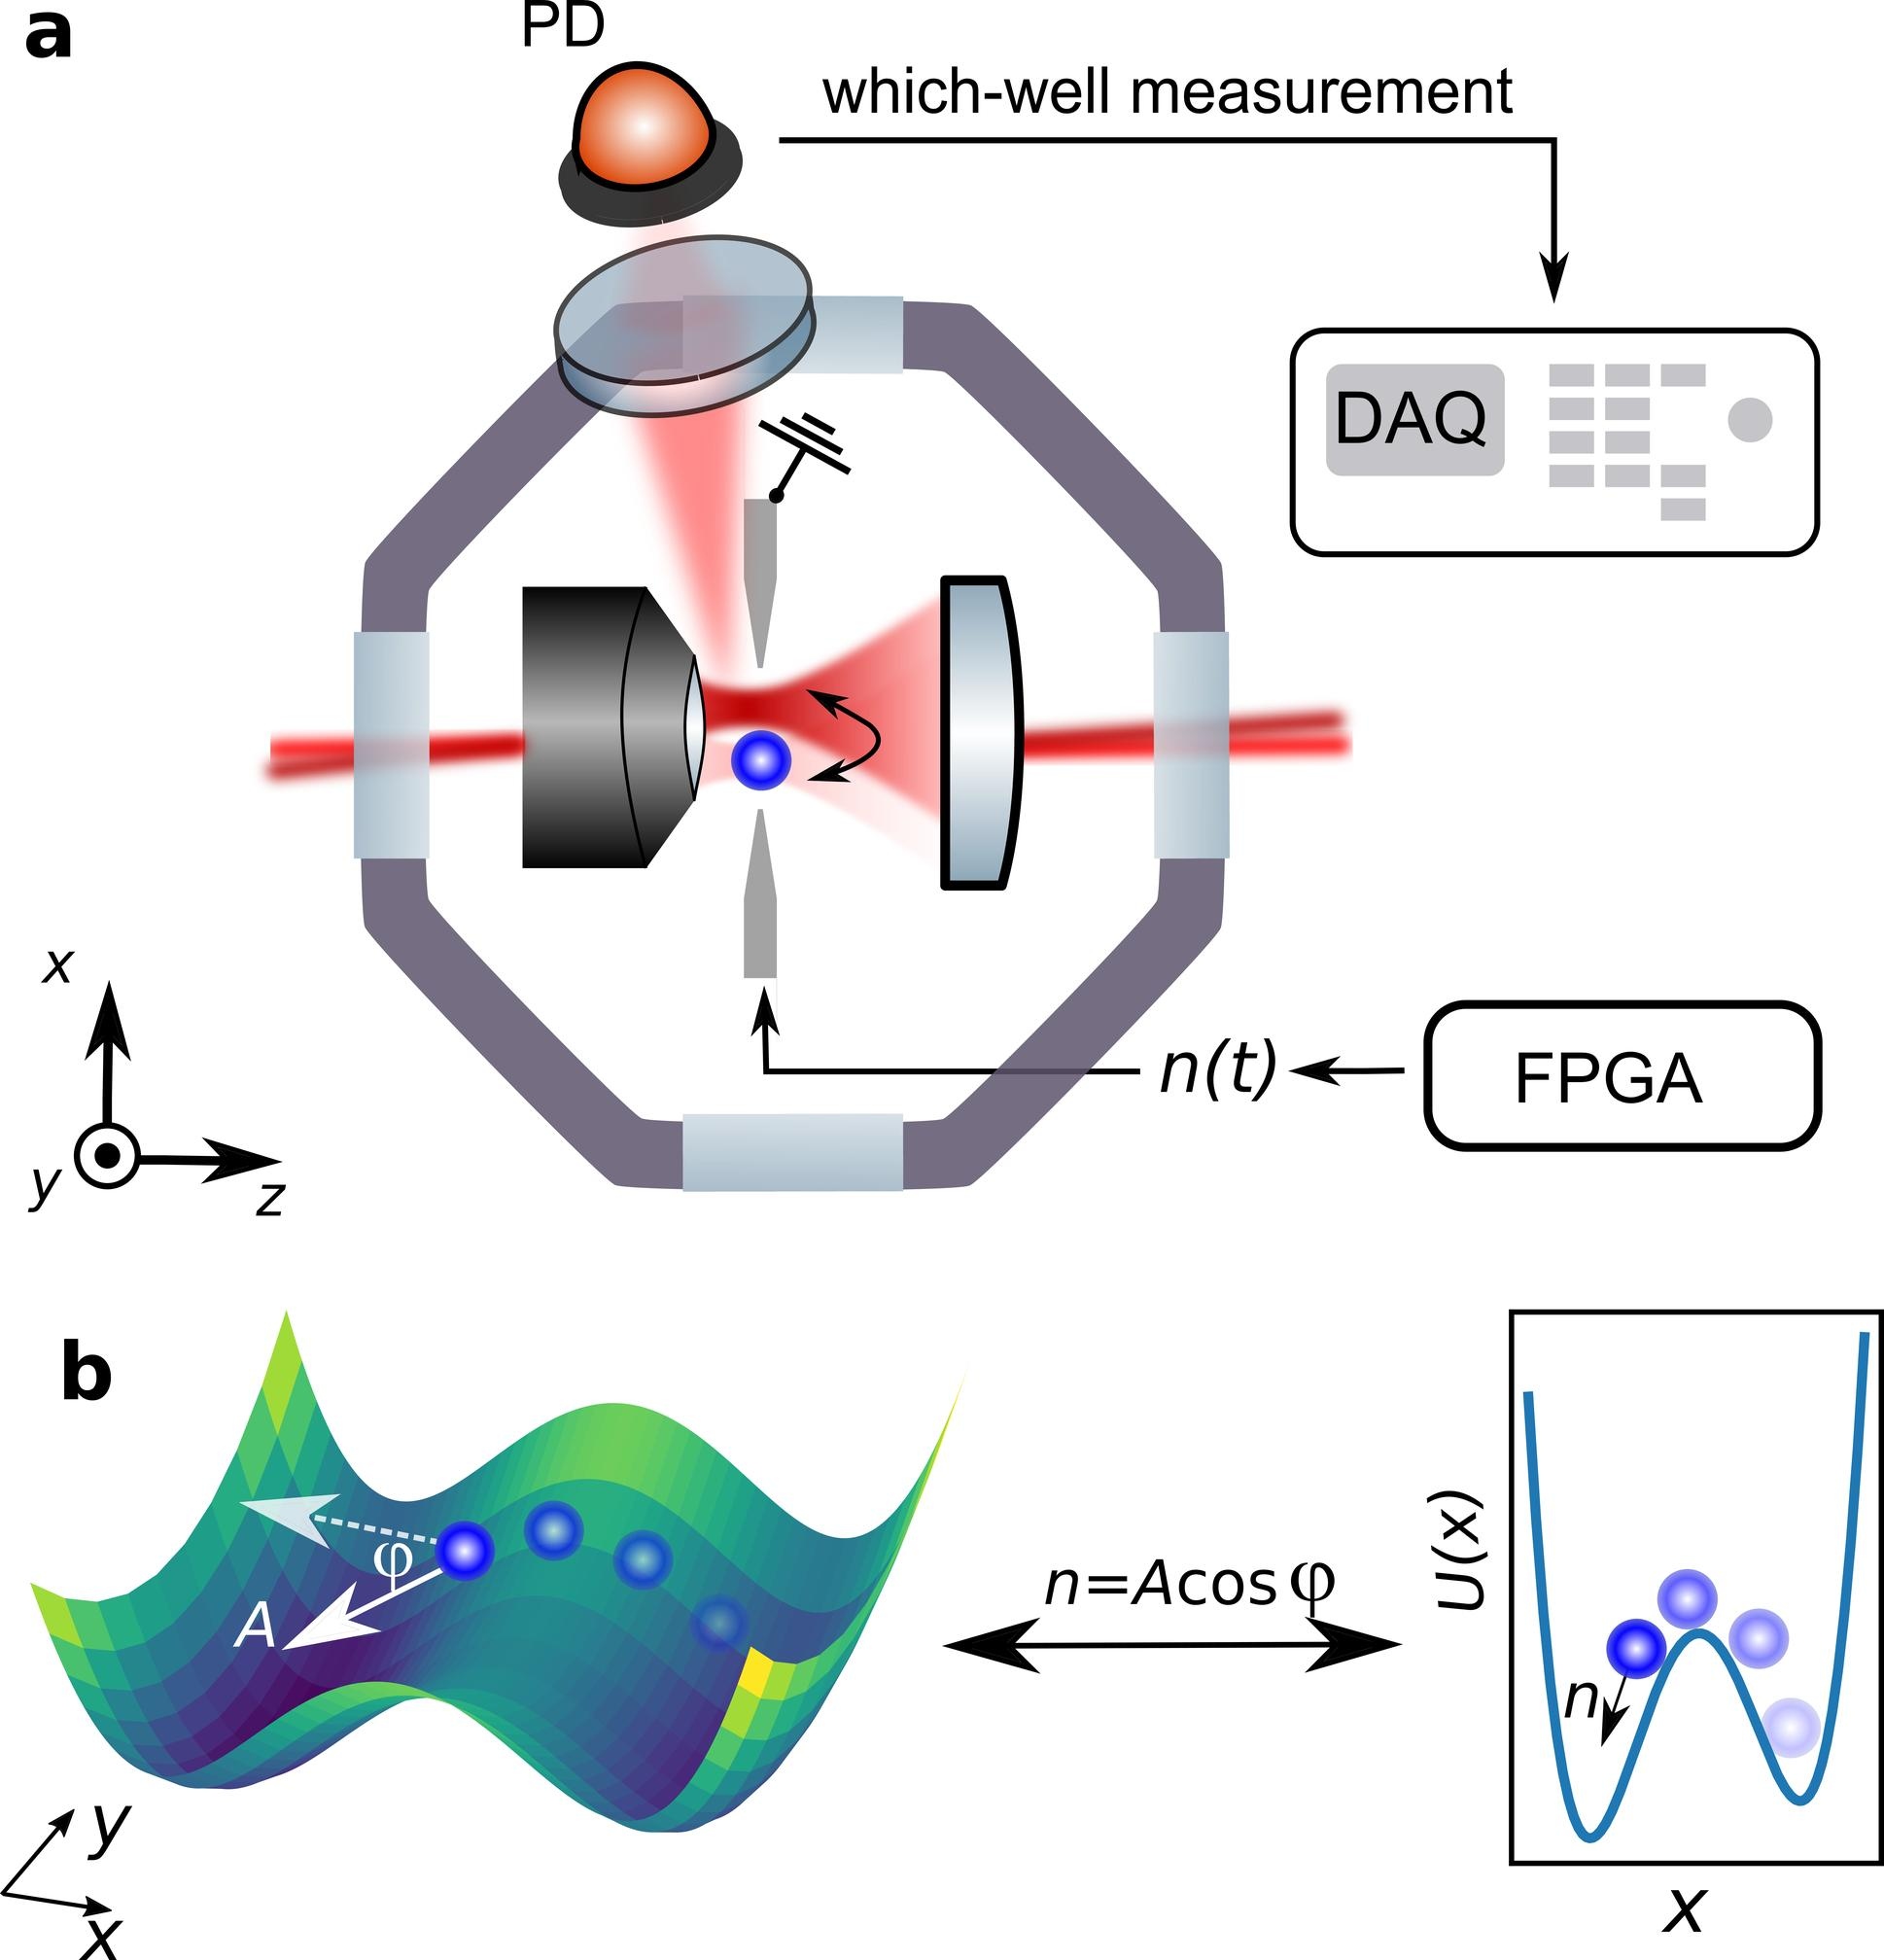What exactly does the graph in part b depict, and how does it relate to the practical setup shown in part a? The graph in part b of the image illustrates a potential energy landscape, visualized as a series of wells or dips. Each well represents a stable state, and the particles (depicted as blue circles) can oscillate between these states. This graphical representation corresponds to the experimental setup described in part a, where a physical system, potentially involving optical elements and tracking via DAQ and FPGA, controls and measures the dynamics of these particles within similar potentials. Essentially, part b provides a theoretical model explaining the underlying physics explored in the experimental setup of part a. 